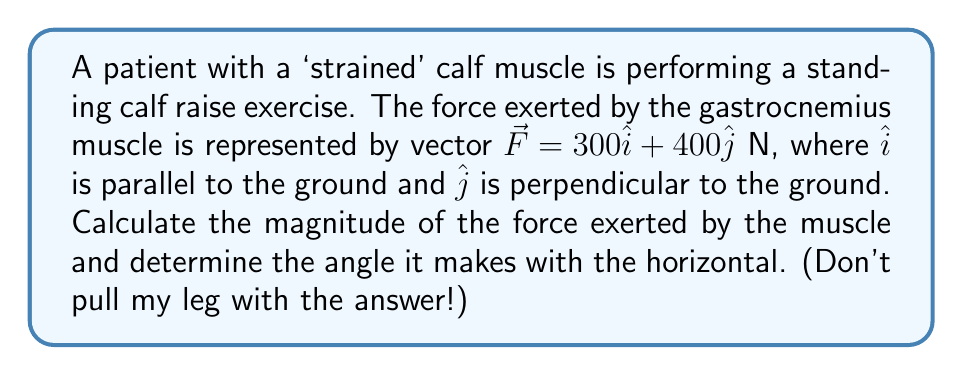Can you answer this question? Let's break this down step by step:

1) The force vector is given as $\vec{F} = 300\hat{i} + 400\hat{j}$ N.

2) To find the magnitude of the force, we use the Pythagorean theorem:

   $$|\vec{F}| = \sqrt{F_x^2 + F_y^2} = \sqrt{300^2 + 400^2}$$

3) Simplify:
   $$|\vec{F}| = \sqrt{90,000 + 160,000} = \sqrt{250,000} = 500 \text{ N}$$

4) To find the angle $\theta$ that the force makes with the horizontal, we use the arctangent function:

   $$\theta = \tan^{-1}\left(\frac{F_y}{F_x}\right) = \tan^{-1}\left(\frac{400}{300}\right)$$

5) Calculate:
   $$\theta = \tan^{-1}\left(\frac{4}{3}\right) \approx 53.13^\circ$$

Therefore, the magnitude of the force is 500 N, and it makes an angle of approximately 53.13° with the horizontal.
Answer: 500 N, 53.13° 